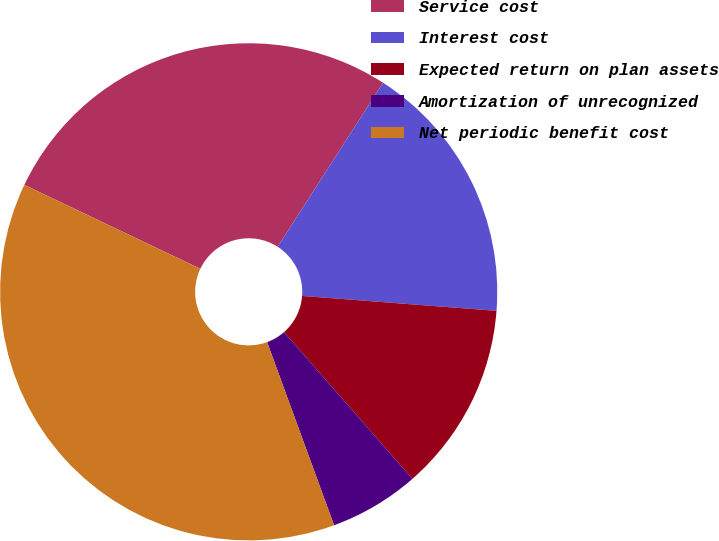Convert chart to OTSL. <chart><loc_0><loc_0><loc_500><loc_500><pie_chart><fcel>Service cost<fcel>Interest cost<fcel>Expected return on plan assets<fcel>Amortization of unrecognized<fcel>Net periodic benefit cost<nl><fcel>27.01%<fcel>17.13%<fcel>12.34%<fcel>5.86%<fcel>37.66%<nl></chart> 